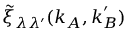<formula> <loc_0><loc_0><loc_500><loc_500>\tilde { \xi } _ { \lambda \lambda ^ { \prime } } ( k _ { A } , k _ { B } ^ { \prime } )</formula> 